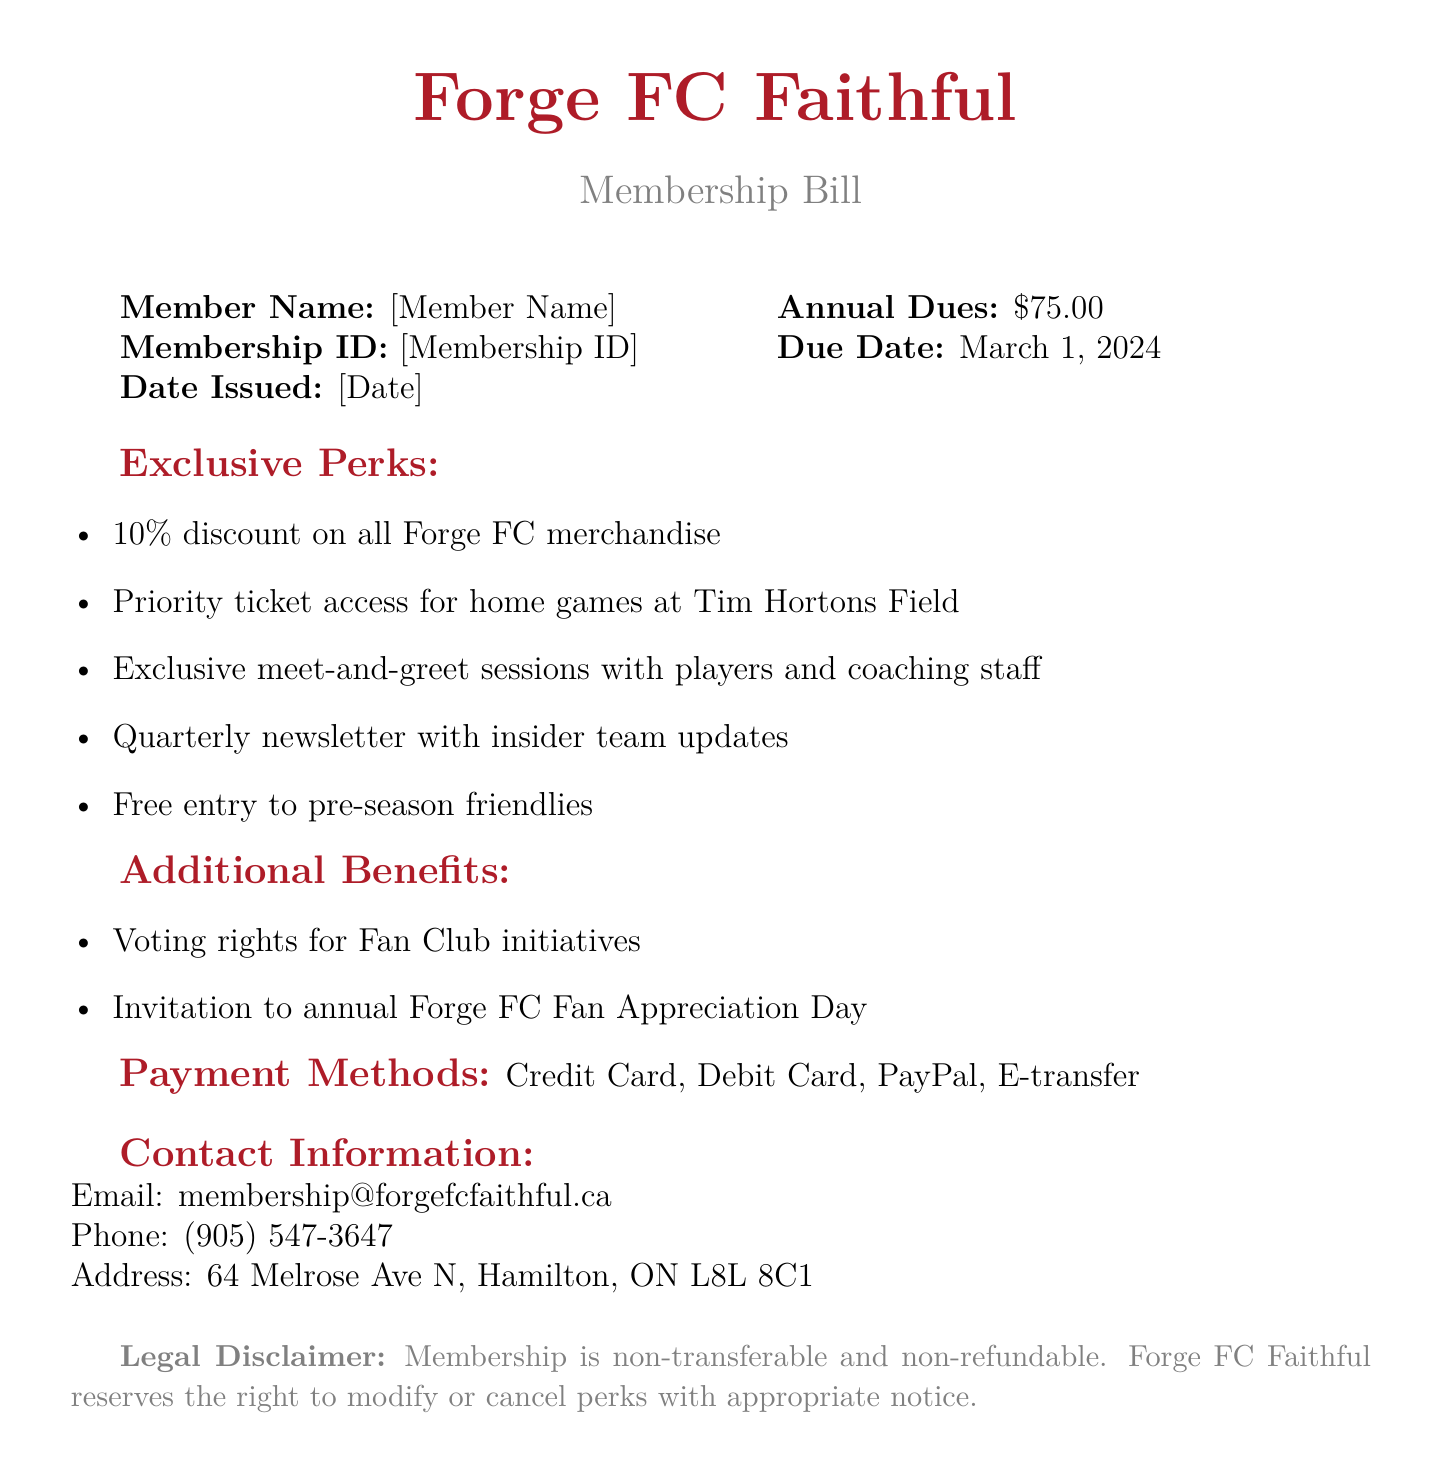what is the membership ID? The membership ID is a unique identifier listed in the document, represented as [Membership ID].
Answer: [Membership ID] what is the annual dues for membership? The document specifies the cost of membership dues, which is stated as $75.00.
Answer: $75.00 when is the due date for payment? The due date is clearly mentioned in the document and falls on March 1, 2024.
Answer: March 1, 2024 what percentage discount do members receive on merchandise? The membership benefits include a 10% discount on all Forge FC merchandise.
Answer: 10% what event do members get invited to annually? The document states that members receive an invitation to the annual Forge FC Fan Appreciation Day.
Answer: Forge FC Fan Appreciation Day what methods of payment are accepted? The document outlines the payment methods accepted for the membership dues as Credit Card, Debit Card, PayPal, and E-transfer.
Answer: Credit Card, Debit Card, PayPal, E-transfer what kind of exclusive sessions can members attend? Members have the opportunity to attend exclusive meet-and-greet sessions with players and coaching staff.
Answer: meet-and-greet sessions is the membership refundable? The legal disclaimer in the document indicates that the membership is non-transferable and non-refundable.
Answer: non-refundable how often do members receive newsletters? The document mentions that members will receive a quarterly newsletter with insider team updates.
Answer: quarterly 